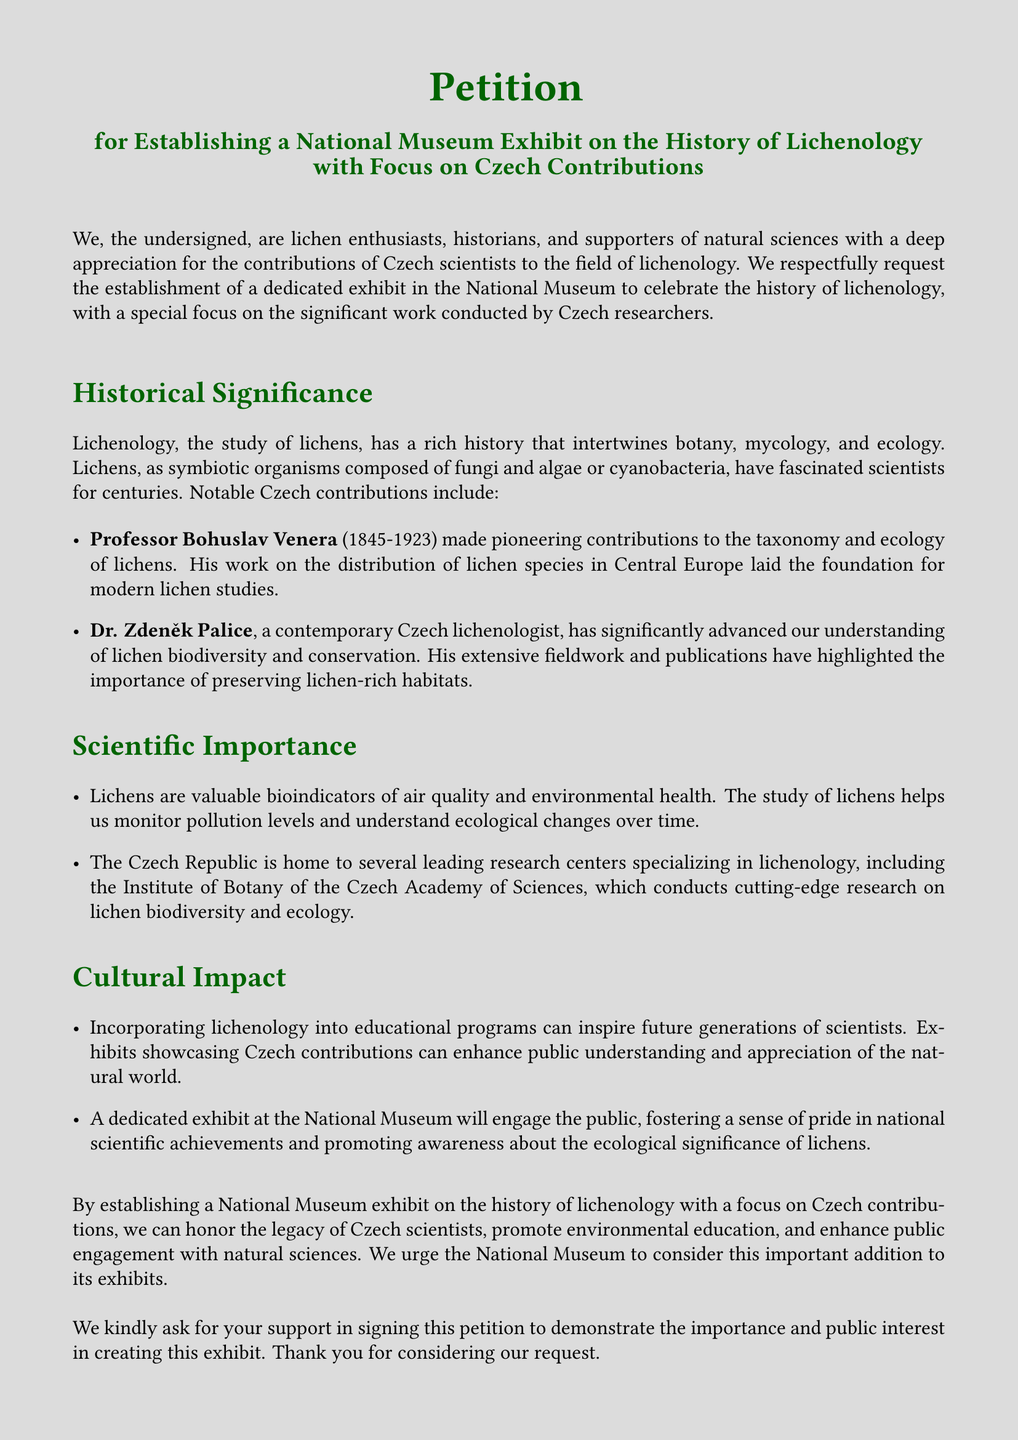What is the title of the petition? The title of the petition explicitly states its purpose, which is "for Establishing a National Museum Exhibit on the History of Lichenology with Focus on Czech Contributions."
Answer: for Establishing a National Museum Exhibit on the History of Lichenology with Focus on Czech Contributions Who is a notable Czech lichenologist mentioned in the petition? The petition mentions Professor Bohuslav Venera and Dr. Zdeněk Palice as notable Czech lichenologists who contributed to the field.
Answer: Professor Bohuslav Venera What years did Professor Bohuslav Venera live? The document provides the lifespan of Professor Bohuslav Venera as spanning from 1845 to 1923.
Answer: 1845-1923 What is one ecological role of lichens mentioned in the petition? The petition states that lichens serve as "valuable bioindicators of air quality and environmental health," indicating their role in monitoring environmental conditions.
Answer: bioindicators of air quality What kind of contributions does the petition advocate for? The petition advocates for contributions that celebrate "the history of lichenology, with a special focus on the significant work conducted by Czech researchers."
Answer: significant work conducted by Czech researchers What is the purpose of the proposed exhibit in the National Museum? The purpose of the proposed exhibit is to "honor the legacy of Czech scientists, promote environmental education, and enhance public engagement with natural sciences."
Answer: honor the legacy of Czech scientists What will incorporating lichenology into educational programs do? According to the petition, it can "inspire future generations of scientists," indicating its potential impact on education.
Answer: inspire future generations of scientists What is the call to action at the end of the petition? The document concludes with a request for public support in "signing this petition to demonstrate the importance and public interest in creating this exhibit."
Answer: signing this petition 